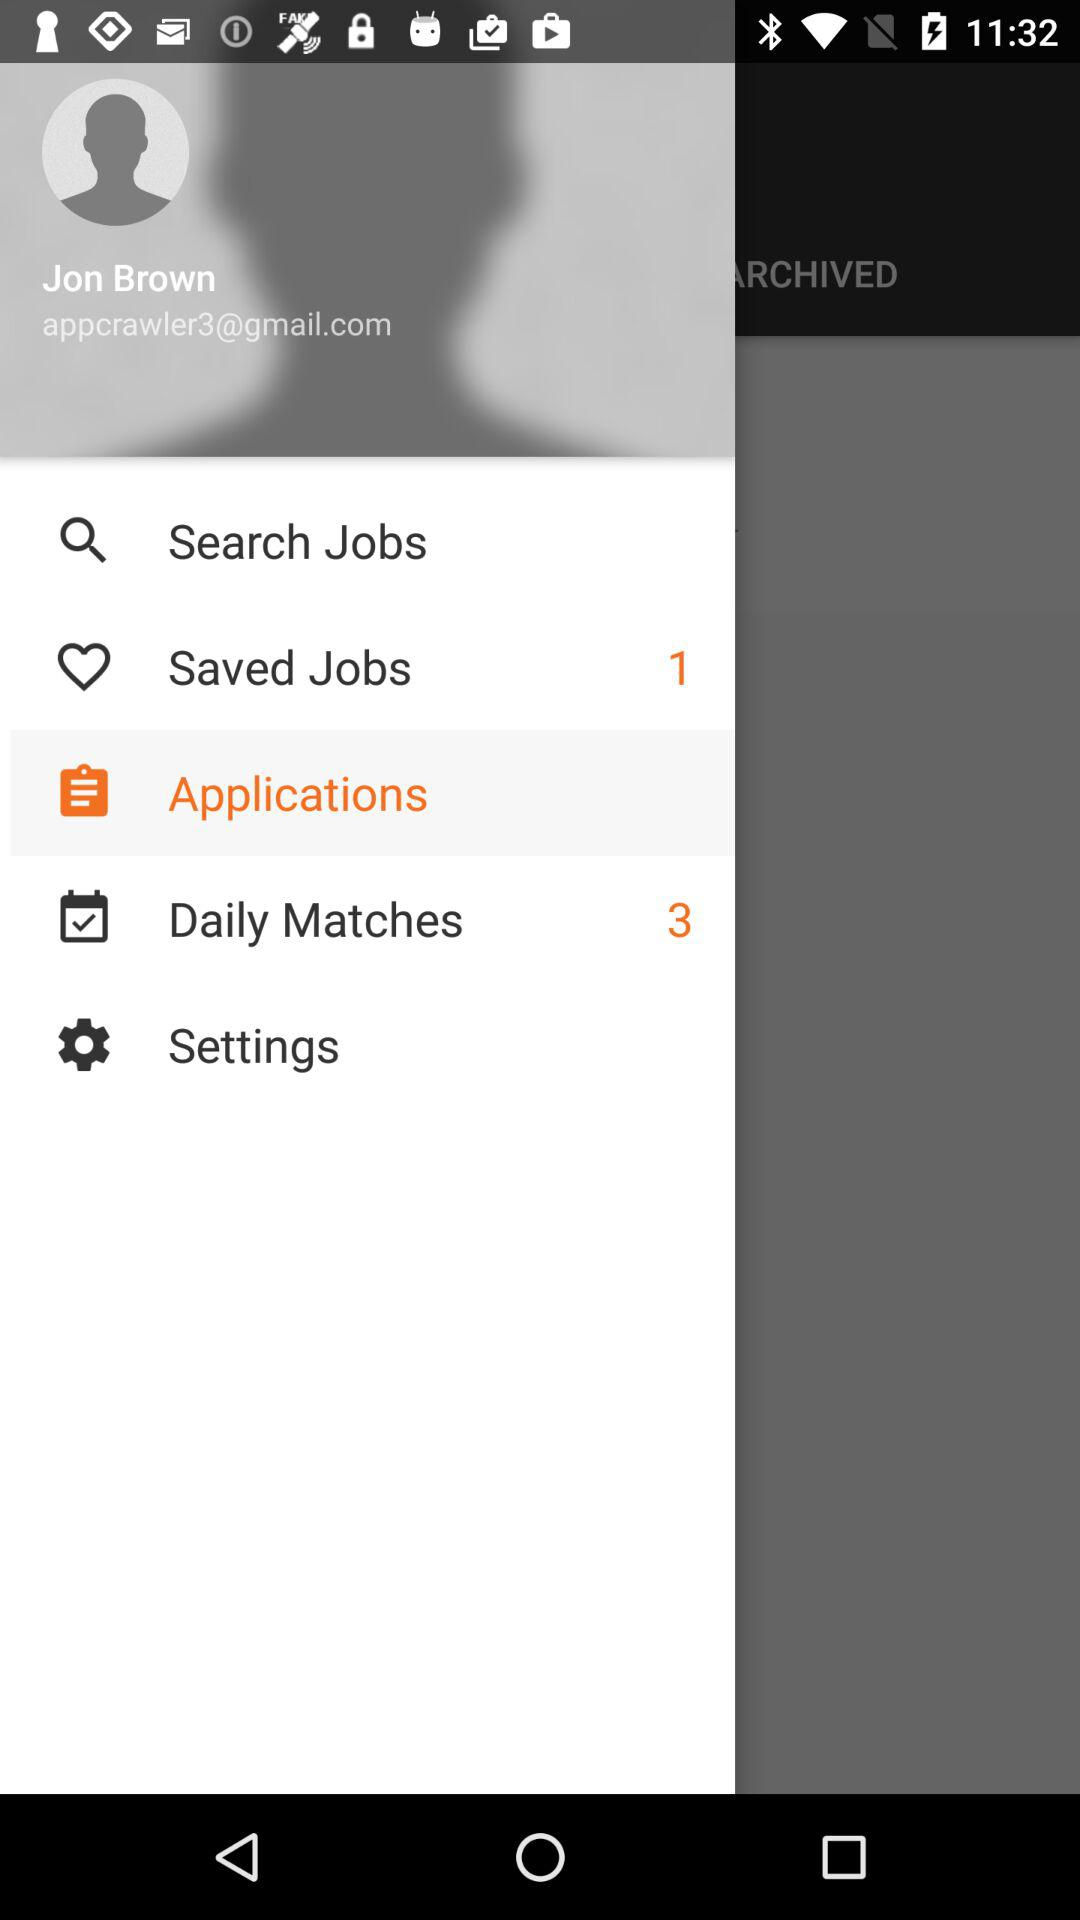How many more daily matches than saved jobs does the user have?
Answer the question using a single word or phrase. 2 